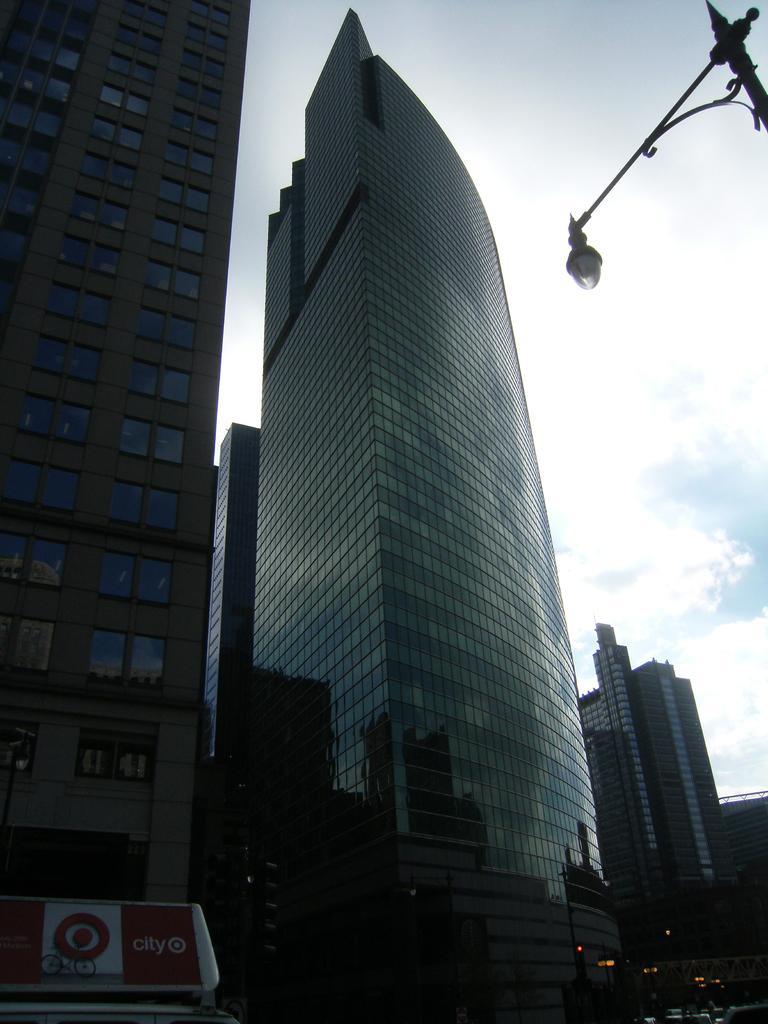In one or two sentences, can you explain what this image depicts? In this image we can see buildings, windows, glass doors and at the bottom we can see a hoarding, light poles, vehicles and bridge. In the background there are clouds in the sky and on the right side there is security camera on a pole. 